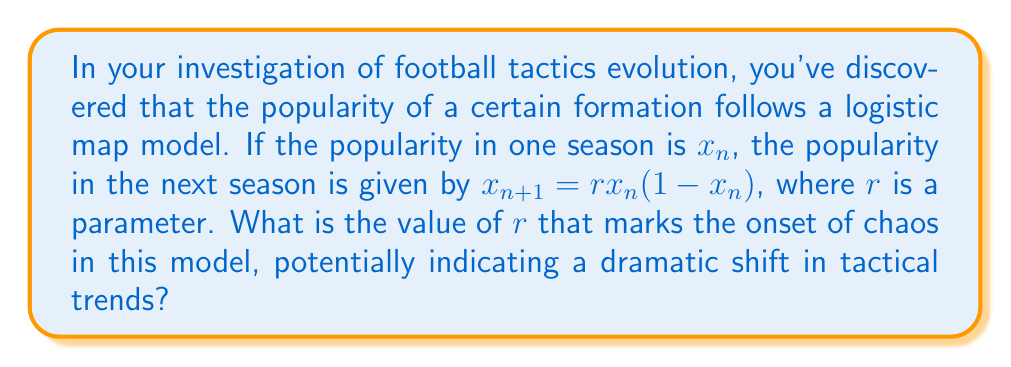What is the answer to this math problem? To find the value of $r$ that marks the onset of chaos in the logistic map model:

1) The logistic map is given by: $x_{n+1} = rx_n(1-x_n)$

2) Chaos occurs when the system becomes sensitive to initial conditions and exhibits period doubling.

3) The onset of chaos is associated with the accumulation point of the period-doubling bifurcations.

4) This point is known as the Feigenbaum point, named after Mitchell Feigenbaum who discovered it.

5) The Feigenbaum point for the logistic map occurs at:

   $$r_{\infty} = 3.569946...$$ 

6) This value is universal for all one-dimensional maps with a quadratic maximum.

7) At this point, the system transitions from periodic behavior to chaos, potentially representing a critical juncture in tactical evolution where small changes in initial conditions lead to vastly different outcomes.
Answer: $3.569946$ 